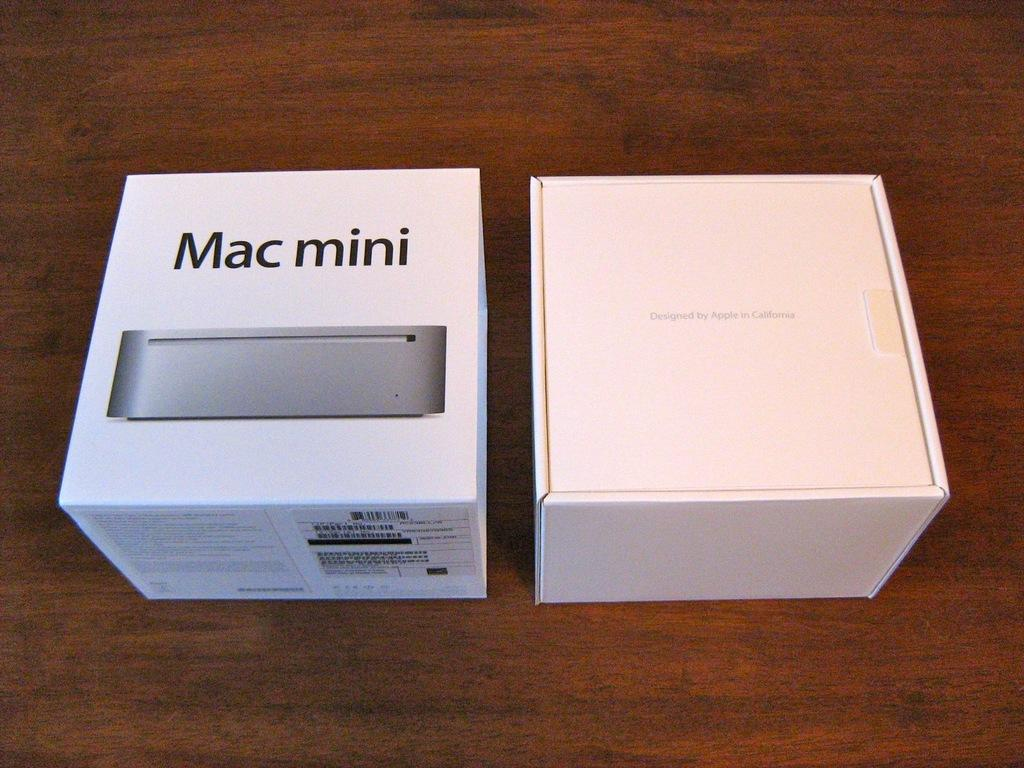<image>
Render a clear and concise summary of the photo. Two white boxes, one for a Mac mini, sit on a table. 